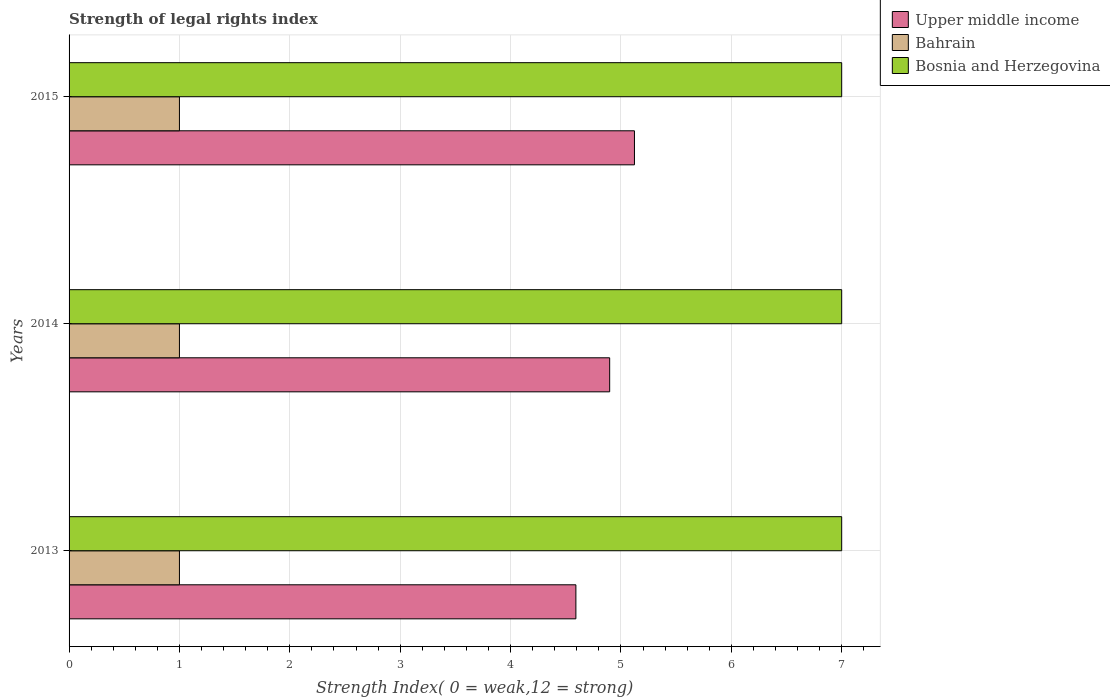How many different coloured bars are there?
Give a very brief answer. 3. How many groups of bars are there?
Your answer should be very brief. 3. Are the number of bars per tick equal to the number of legend labels?
Your answer should be very brief. Yes. Are the number of bars on each tick of the Y-axis equal?
Keep it short and to the point. Yes. What is the strength index in Bahrain in 2014?
Your answer should be compact. 1. Across all years, what is the maximum strength index in Upper middle income?
Your answer should be very brief. 5.12. Across all years, what is the minimum strength index in Bosnia and Herzegovina?
Make the answer very short. 7. What is the total strength index in Bosnia and Herzegovina in the graph?
Offer a very short reply. 21. What is the difference between the strength index in Upper middle income in 2014 and that in 2015?
Your response must be concise. -0.22. What is the difference between the strength index in Bahrain in 2014 and the strength index in Bosnia and Herzegovina in 2015?
Ensure brevity in your answer.  -6. In the year 2014, what is the difference between the strength index in Upper middle income and strength index in Bahrain?
Make the answer very short. 3.9. What is the ratio of the strength index in Upper middle income in 2013 to that in 2015?
Keep it short and to the point. 0.9. Is the strength index in Bahrain in 2014 less than that in 2015?
Provide a succinct answer. No. What is the difference between the highest and the second highest strength index in Bahrain?
Make the answer very short. 0. In how many years, is the strength index in Bosnia and Herzegovina greater than the average strength index in Bosnia and Herzegovina taken over all years?
Offer a very short reply. 0. Is the sum of the strength index in Bahrain in 2013 and 2015 greater than the maximum strength index in Bosnia and Herzegovina across all years?
Provide a short and direct response. No. What does the 1st bar from the top in 2013 represents?
Offer a terse response. Bosnia and Herzegovina. What does the 2nd bar from the bottom in 2015 represents?
Provide a short and direct response. Bahrain. Is it the case that in every year, the sum of the strength index in Upper middle income and strength index in Bahrain is greater than the strength index in Bosnia and Herzegovina?
Your answer should be very brief. No. Are all the bars in the graph horizontal?
Keep it short and to the point. Yes. What is the difference between two consecutive major ticks on the X-axis?
Your answer should be very brief. 1. Are the values on the major ticks of X-axis written in scientific E-notation?
Offer a terse response. No. Does the graph contain any zero values?
Offer a terse response. No. Does the graph contain grids?
Offer a very short reply. Yes. Where does the legend appear in the graph?
Give a very brief answer. Top right. What is the title of the graph?
Offer a terse response. Strength of legal rights index. What is the label or title of the X-axis?
Offer a terse response. Strength Index( 0 = weak,12 = strong). What is the label or title of the Y-axis?
Keep it short and to the point. Years. What is the Strength Index( 0 = weak,12 = strong) in Upper middle income in 2013?
Provide a short and direct response. 4.59. What is the Strength Index( 0 = weak,12 = strong) of Upper middle income in 2014?
Ensure brevity in your answer.  4.9. What is the Strength Index( 0 = weak,12 = strong) in Bahrain in 2014?
Offer a terse response. 1. What is the Strength Index( 0 = weak,12 = strong) of Bosnia and Herzegovina in 2014?
Give a very brief answer. 7. What is the Strength Index( 0 = weak,12 = strong) in Upper middle income in 2015?
Your response must be concise. 5.12. Across all years, what is the maximum Strength Index( 0 = weak,12 = strong) of Upper middle income?
Ensure brevity in your answer.  5.12. Across all years, what is the maximum Strength Index( 0 = weak,12 = strong) in Bahrain?
Offer a terse response. 1. Across all years, what is the maximum Strength Index( 0 = weak,12 = strong) of Bosnia and Herzegovina?
Offer a very short reply. 7. Across all years, what is the minimum Strength Index( 0 = weak,12 = strong) in Upper middle income?
Your answer should be very brief. 4.59. What is the total Strength Index( 0 = weak,12 = strong) of Upper middle income in the graph?
Give a very brief answer. 14.61. What is the total Strength Index( 0 = weak,12 = strong) of Bosnia and Herzegovina in the graph?
Offer a terse response. 21. What is the difference between the Strength Index( 0 = weak,12 = strong) of Upper middle income in 2013 and that in 2014?
Your answer should be very brief. -0.31. What is the difference between the Strength Index( 0 = weak,12 = strong) in Bahrain in 2013 and that in 2014?
Ensure brevity in your answer.  0. What is the difference between the Strength Index( 0 = weak,12 = strong) of Bosnia and Herzegovina in 2013 and that in 2014?
Your answer should be compact. 0. What is the difference between the Strength Index( 0 = weak,12 = strong) of Upper middle income in 2013 and that in 2015?
Offer a very short reply. -0.53. What is the difference between the Strength Index( 0 = weak,12 = strong) in Bosnia and Herzegovina in 2013 and that in 2015?
Provide a short and direct response. 0. What is the difference between the Strength Index( 0 = weak,12 = strong) in Upper middle income in 2014 and that in 2015?
Give a very brief answer. -0.22. What is the difference between the Strength Index( 0 = weak,12 = strong) of Bosnia and Herzegovina in 2014 and that in 2015?
Ensure brevity in your answer.  0. What is the difference between the Strength Index( 0 = weak,12 = strong) of Upper middle income in 2013 and the Strength Index( 0 = weak,12 = strong) of Bahrain in 2014?
Your answer should be very brief. 3.59. What is the difference between the Strength Index( 0 = weak,12 = strong) in Upper middle income in 2013 and the Strength Index( 0 = weak,12 = strong) in Bosnia and Herzegovina in 2014?
Your answer should be very brief. -2.41. What is the difference between the Strength Index( 0 = weak,12 = strong) of Bahrain in 2013 and the Strength Index( 0 = weak,12 = strong) of Bosnia and Herzegovina in 2014?
Offer a very short reply. -6. What is the difference between the Strength Index( 0 = weak,12 = strong) in Upper middle income in 2013 and the Strength Index( 0 = weak,12 = strong) in Bahrain in 2015?
Your answer should be compact. 3.59. What is the difference between the Strength Index( 0 = weak,12 = strong) in Upper middle income in 2013 and the Strength Index( 0 = weak,12 = strong) in Bosnia and Herzegovina in 2015?
Provide a short and direct response. -2.41. What is the difference between the Strength Index( 0 = weak,12 = strong) in Upper middle income in 2014 and the Strength Index( 0 = weak,12 = strong) in Bahrain in 2015?
Offer a terse response. 3.9. What is the difference between the Strength Index( 0 = weak,12 = strong) in Upper middle income in 2014 and the Strength Index( 0 = weak,12 = strong) in Bosnia and Herzegovina in 2015?
Your response must be concise. -2.1. What is the difference between the Strength Index( 0 = weak,12 = strong) in Bahrain in 2014 and the Strength Index( 0 = weak,12 = strong) in Bosnia and Herzegovina in 2015?
Your answer should be very brief. -6. What is the average Strength Index( 0 = weak,12 = strong) of Upper middle income per year?
Ensure brevity in your answer.  4.87. In the year 2013, what is the difference between the Strength Index( 0 = weak,12 = strong) in Upper middle income and Strength Index( 0 = weak,12 = strong) in Bahrain?
Your response must be concise. 3.59. In the year 2013, what is the difference between the Strength Index( 0 = weak,12 = strong) in Upper middle income and Strength Index( 0 = weak,12 = strong) in Bosnia and Herzegovina?
Your response must be concise. -2.41. In the year 2014, what is the difference between the Strength Index( 0 = weak,12 = strong) of Upper middle income and Strength Index( 0 = weak,12 = strong) of Bahrain?
Your answer should be very brief. 3.9. In the year 2014, what is the difference between the Strength Index( 0 = weak,12 = strong) of Upper middle income and Strength Index( 0 = weak,12 = strong) of Bosnia and Herzegovina?
Give a very brief answer. -2.1. In the year 2014, what is the difference between the Strength Index( 0 = weak,12 = strong) of Bahrain and Strength Index( 0 = weak,12 = strong) of Bosnia and Herzegovina?
Offer a terse response. -6. In the year 2015, what is the difference between the Strength Index( 0 = weak,12 = strong) of Upper middle income and Strength Index( 0 = weak,12 = strong) of Bahrain?
Offer a very short reply. 4.12. In the year 2015, what is the difference between the Strength Index( 0 = weak,12 = strong) in Upper middle income and Strength Index( 0 = weak,12 = strong) in Bosnia and Herzegovina?
Your answer should be very brief. -1.88. What is the ratio of the Strength Index( 0 = weak,12 = strong) of Bosnia and Herzegovina in 2013 to that in 2014?
Your answer should be very brief. 1. What is the ratio of the Strength Index( 0 = weak,12 = strong) of Upper middle income in 2013 to that in 2015?
Ensure brevity in your answer.  0.9. What is the ratio of the Strength Index( 0 = weak,12 = strong) in Bosnia and Herzegovina in 2013 to that in 2015?
Your answer should be compact. 1. What is the ratio of the Strength Index( 0 = weak,12 = strong) in Upper middle income in 2014 to that in 2015?
Offer a terse response. 0.96. What is the ratio of the Strength Index( 0 = weak,12 = strong) in Bahrain in 2014 to that in 2015?
Your answer should be compact. 1. What is the ratio of the Strength Index( 0 = weak,12 = strong) of Bosnia and Herzegovina in 2014 to that in 2015?
Offer a very short reply. 1. What is the difference between the highest and the second highest Strength Index( 0 = weak,12 = strong) of Upper middle income?
Provide a short and direct response. 0.22. What is the difference between the highest and the second highest Strength Index( 0 = weak,12 = strong) of Bosnia and Herzegovina?
Keep it short and to the point. 0. What is the difference between the highest and the lowest Strength Index( 0 = weak,12 = strong) of Upper middle income?
Provide a succinct answer. 0.53. 